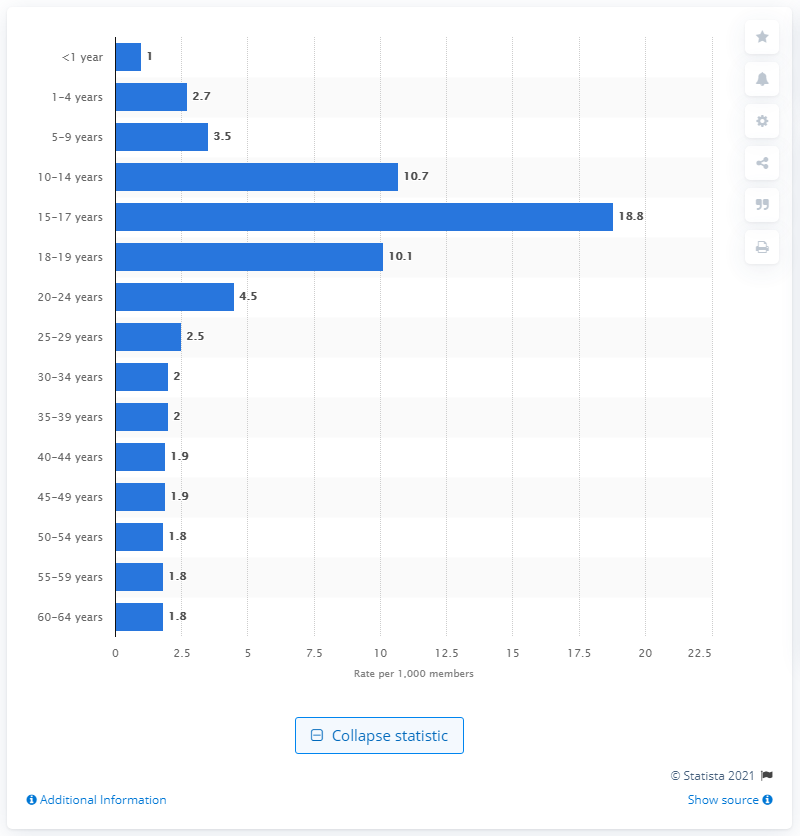List a handful of essential elements in this visual. The 15-17 age group had the highest rate of concussions between 2010 and 2015, according to data. 